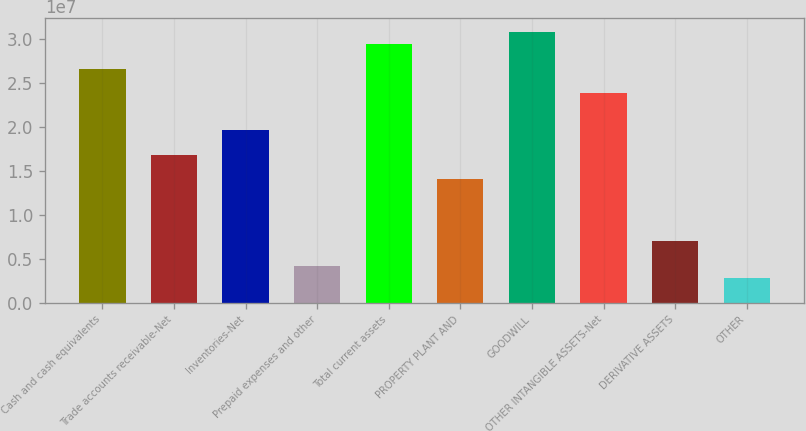Convert chart to OTSL. <chart><loc_0><loc_0><loc_500><loc_500><bar_chart><fcel>Cash and cash equivalents<fcel>Trade accounts receivable-Net<fcel>Inventories-Net<fcel>Prepaid expenses and other<fcel>Total current assets<fcel>PROPERTY PLANT AND<fcel>GOODWILL<fcel>OTHER INTANGIBLE ASSETS-Net<fcel>DERIVATIVE ASSETS<fcel>OTHER<nl><fcel>2.66108e+07<fcel>1.6807e+07<fcel>1.96081e+07<fcel>4.20218e+06<fcel>2.94118e+07<fcel>1.40059e+07<fcel>3.08124e+07<fcel>2.38097e+07<fcel>7.00325e+06<fcel>2.80164e+06<nl></chart> 